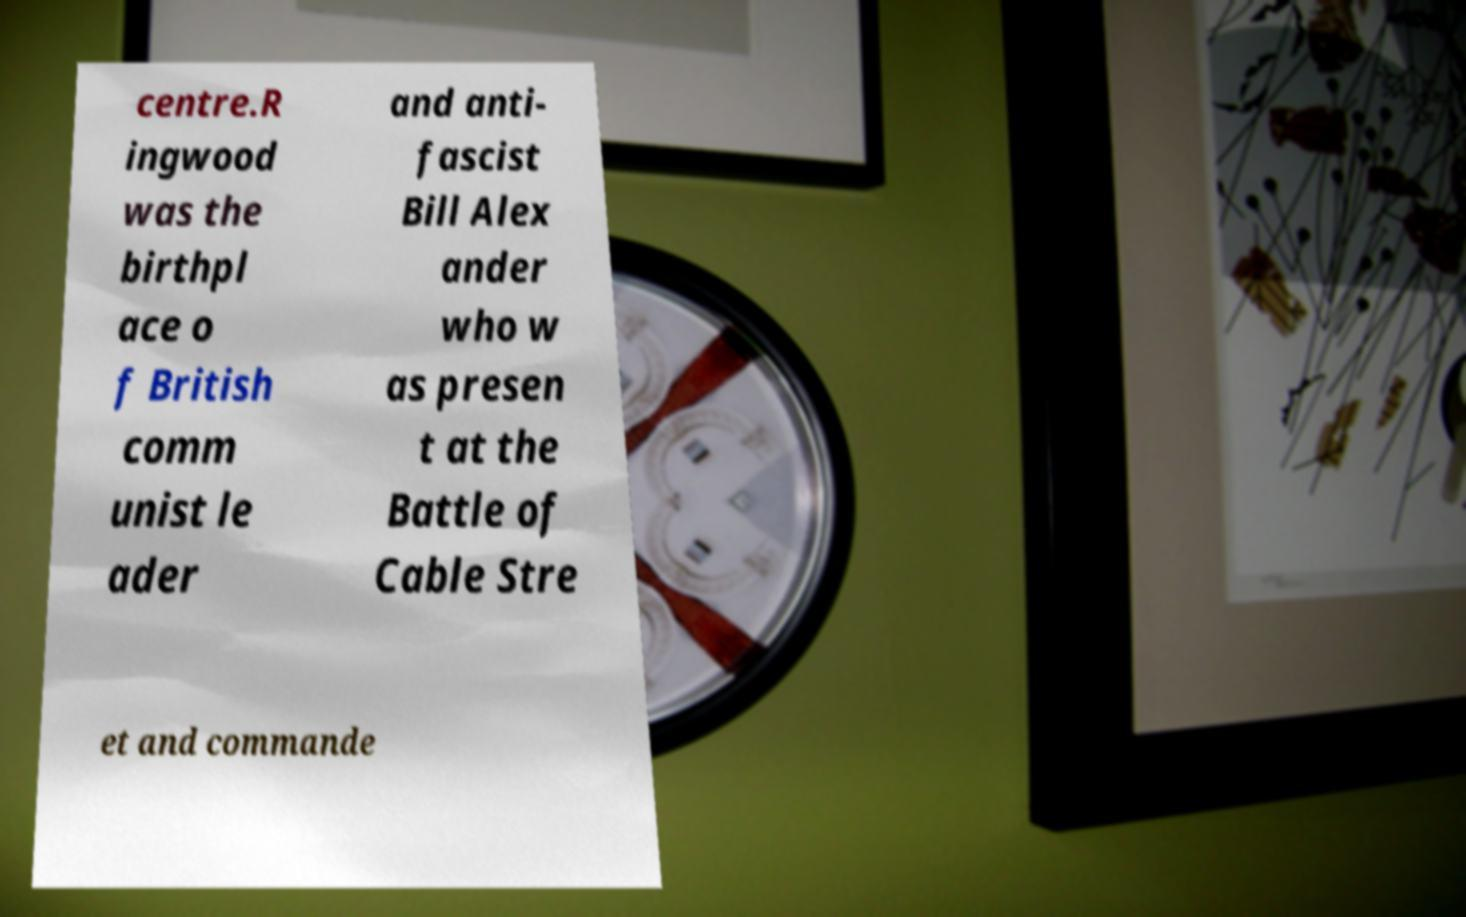Can you accurately transcribe the text from the provided image for me? centre.R ingwood was the birthpl ace o f British comm unist le ader and anti- fascist Bill Alex ander who w as presen t at the Battle of Cable Stre et and commande 